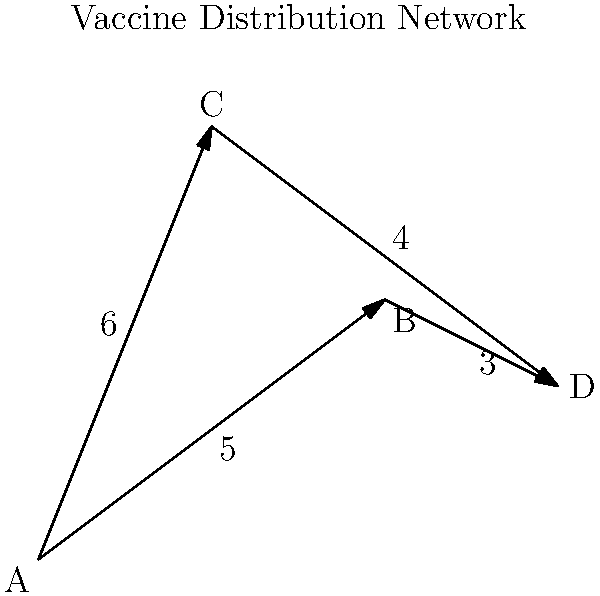As a pharmaceutical company representative, you are tasked with determining the most cost-effective route for distributing vaccines from city A to city D. The map shows the distribution network with distances (in hours) between cities. What is the shortest time required to transport vaccines from A to D, and which path should be taken? To solve this problem, we need to consider all possible paths from A to D and calculate their total times:

1. Path A → B → D:
   Time = AB + BD = 5 + 3 = 8 hours

2. Path A → C → D:
   Time = AC + CD = 6 + 4 = 10 hours

Step-by-step calculation:
1. Calculate time for A → B → D:
   $T_{ABD} = T_{AB} + T_{BD} = 5 + 3 = 8$ hours

2. Calculate time for A → C → D:
   $T_{ACD} = T_{AC} + T_{CD} = 6 + 4 = 10$ hours

3. Compare the two paths:
   $T_{ABD} = 8 < T_{ACD} = 10$

Therefore, the shortest time required to transport vaccines from A to D is 8 hours, and the optimal path is A → B → D.
Answer: 8 hours via A → B → D 